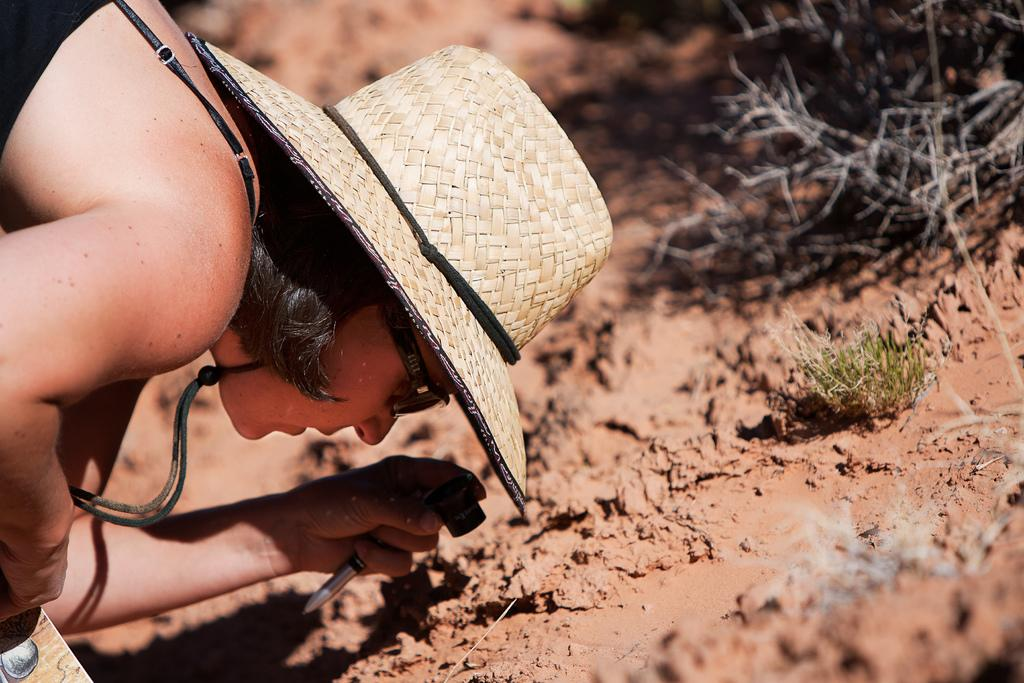What is the main subject in the foreground of the image? There is a woman in the foreground of the image. What is the woman wearing on her head? The woman is wearing a hat. What is the woman holding in her hands? The woman is holding objects. What type of terrain can be seen in the image? There is mud and grass in the image. What type of vegetation is present without leaves? There are branches without leaves in the image. What type of fruit can be seen growing on the branches in the image? There are no fruit visible on the branches in the image; they are branches without leaves. What type of soda is the woman drinking in the image? There is no soda present in the image; the woman is holding objects, but no beverages are mentioned. 